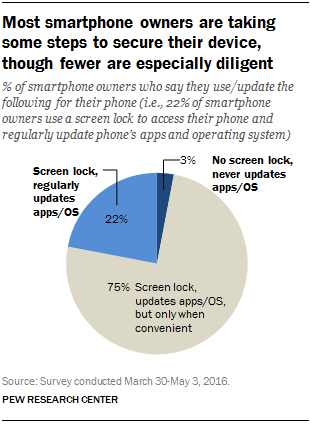Outline some significant characteristics in this image. The value of the largest segment is 0.75. The percentage value of the gray segment is 75%. 